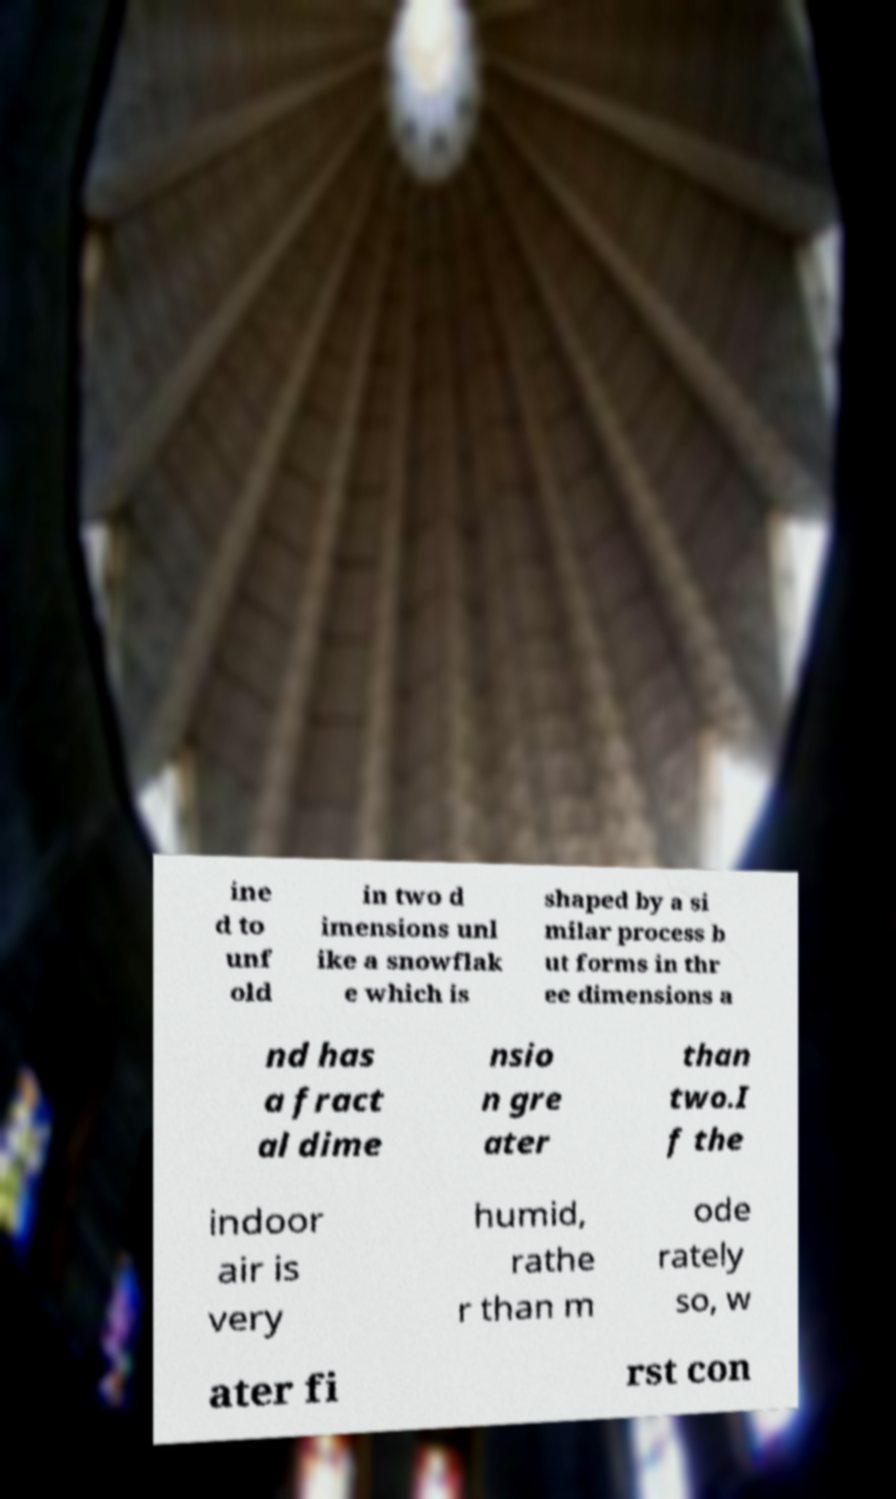Could you assist in decoding the text presented in this image and type it out clearly? ine d to unf old in two d imensions unl ike a snowflak e which is shaped by a si milar process b ut forms in thr ee dimensions a nd has a fract al dime nsio n gre ater than two.I f the indoor air is very humid, rathe r than m ode rately so, w ater fi rst con 